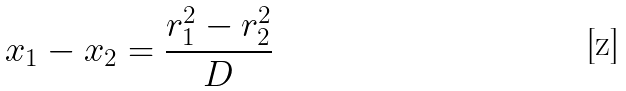Convert formula to latex. <formula><loc_0><loc_0><loc_500><loc_500>x _ { 1 } - x _ { 2 } = \frac { r _ { 1 } ^ { 2 } - r _ { 2 } ^ { 2 } } { D }</formula> 